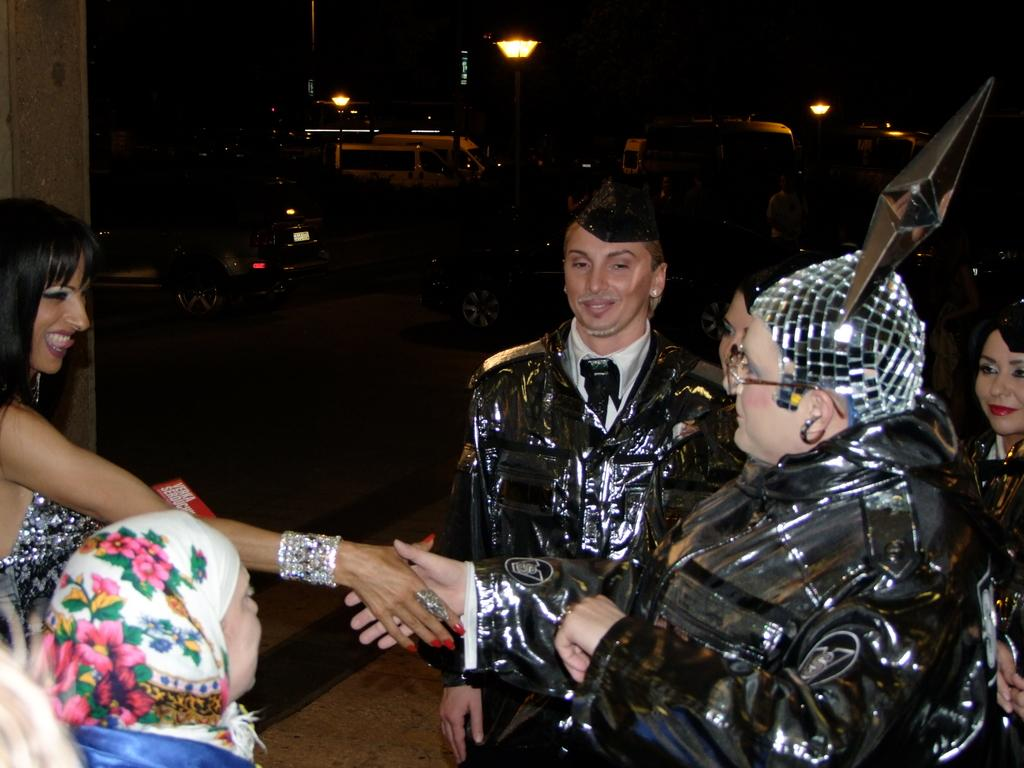Who is present in the image? There are people in the image. What are the two people doing? Two people are shaking hands. What can be seen in the background of the image? There are vehicles and street lights in the background of the image. What type of cave can be seen in the background of the image? There is no cave present in the image; it features people shaking hands and vehicles and street lights in the background. 